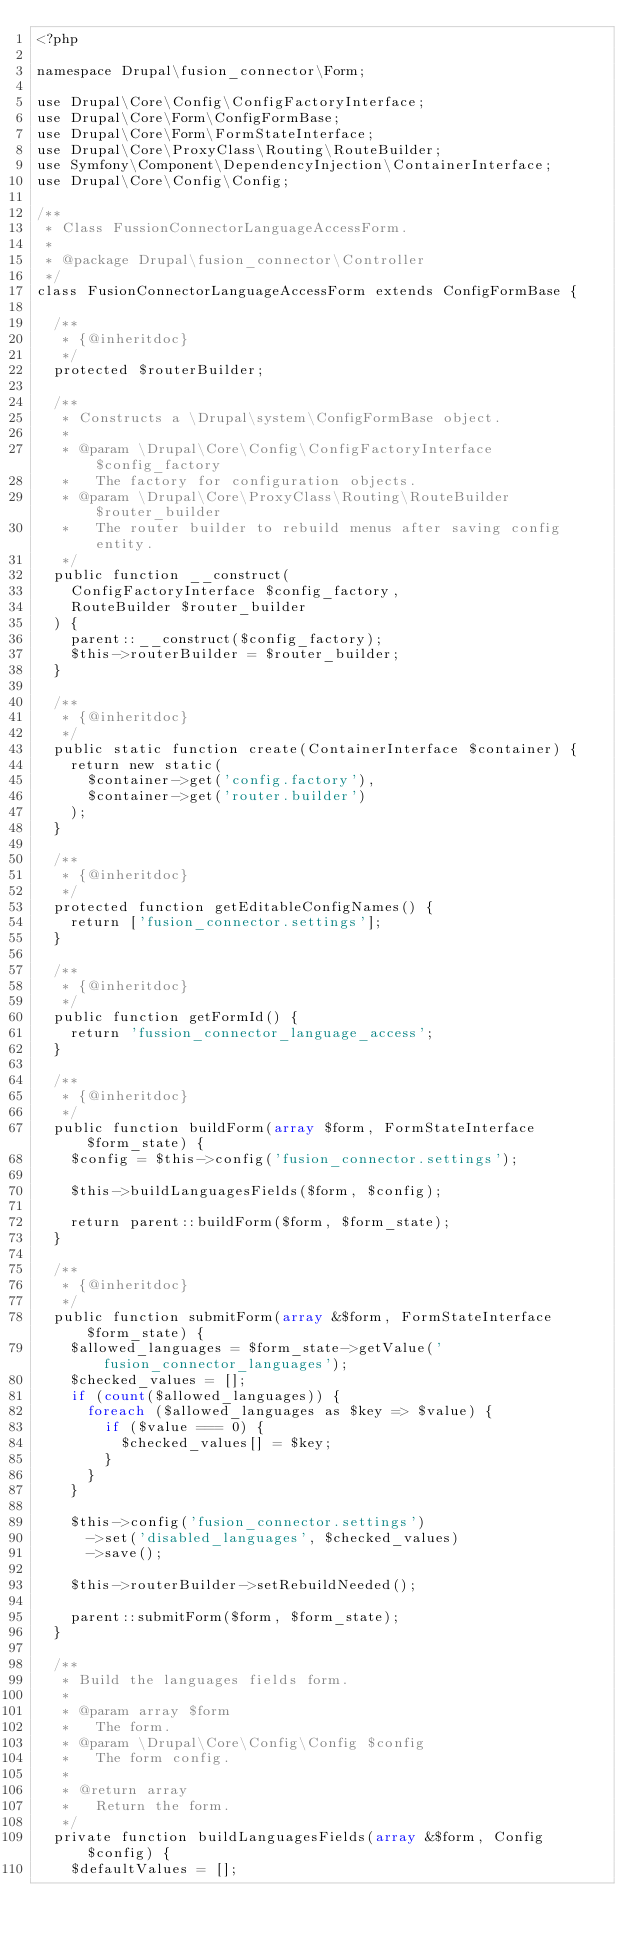Convert code to text. <code><loc_0><loc_0><loc_500><loc_500><_PHP_><?php

namespace Drupal\fusion_connector\Form;

use Drupal\Core\Config\ConfigFactoryInterface;
use Drupal\Core\Form\ConfigFormBase;
use Drupal\Core\Form\FormStateInterface;
use Drupal\Core\ProxyClass\Routing\RouteBuilder;
use Symfony\Component\DependencyInjection\ContainerInterface;
use Drupal\Core\Config\Config;

/**
 * Class FussionConnectorLanguageAccessForm.
 *
 * @package Drupal\fusion_connector\Controller
 */
class FusionConnectorLanguageAccessForm extends ConfigFormBase {

  /**
   * {@inheritdoc}
   */
  protected $routerBuilder;

  /**
   * Constructs a \Drupal\system\ConfigFormBase object.
   *
   * @param \Drupal\Core\Config\ConfigFactoryInterface $config_factory
   *   The factory for configuration objects.
   * @param \Drupal\Core\ProxyClass\Routing\RouteBuilder $router_builder
   *   The router builder to rebuild menus after saving config entity.
   */
  public function __construct(
    ConfigFactoryInterface $config_factory,
    RouteBuilder $router_builder
  ) {
    parent::__construct($config_factory);
    $this->routerBuilder = $router_builder;
  }

  /**
   * {@inheritdoc}
   */
  public static function create(ContainerInterface $container) {
    return new static(
      $container->get('config.factory'),
      $container->get('router.builder')
    );
  }

  /**
   * {@inheritdoc}
   */
  protected function getEditableConfigNames() {
    return ['fusion_connector.settings'];
  }

  /**
   * {@inheritdoc}
   */
  public function getFormId() {
    return 'fussion_connector_language_access';
  }

  /**
   * {@inheritdoc}
   */
  public function buildForm(array $form, FormStateInterface $form_state) {
    $config = $this->config('fusion_connector.settings');

    $this->buildLanguagesFields($form, $config);

    return parent::buildForm($form, $form_state);
  }

  /**
   * {@inheritdoc}
   */
  public function submitForm(array &$form, FormStateInterface $form_state) {
    $allowed_languages = $form_state->getValue('fusion_connector_languages');
    $checked_values = [];
    if (count($allowed_languages)) {
      foreach ($allowed_languages as $key => $value) {
        if ($value === 0) {
          $checked_values[] = $key;
        }
      }
    }

    $this->config('fusion_connector.settings')
      ->set('disabled_languages', $checked_values)
      ->save();

    $this->routerBuilder->setRebuildNeeded();

    parent::submitForm($form, $form_state);
  }

  /**
   * Build the languages fields form.
   *
   * @param array $form
   *   The form.
   * @param \Drupal\Core\Config\Config $config
   *   The form config.
   *
   * @return array
   *   Return the form.
   */
  private function buildLanguagesFields(array &$form, Config $config) {
    $defaultValues = [];</code> 